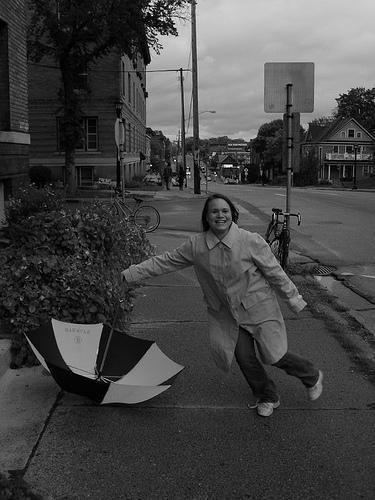How many bikes are in this scene?
Give a very brief answer. 2. How many umbrellas are there on the sidewalk?
Give a very brief answer. 1. 